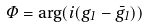Convert formula to latex. <formula><loc_0><loc_0><loc_500><loc_500>\Phi = \arg ( i ( g _ { 1 } - \bar { g } _ { 1 } ) )</formula> 